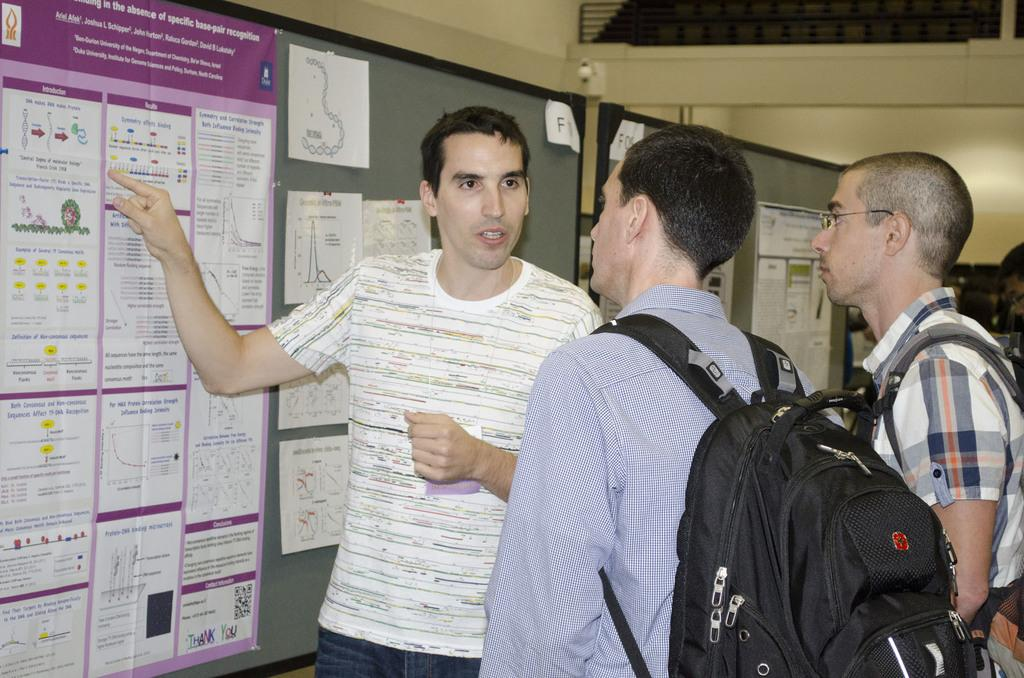<image>
Create a compact narrative representing the image presented. Man pointing at a bulletin board that says "Introduction". 